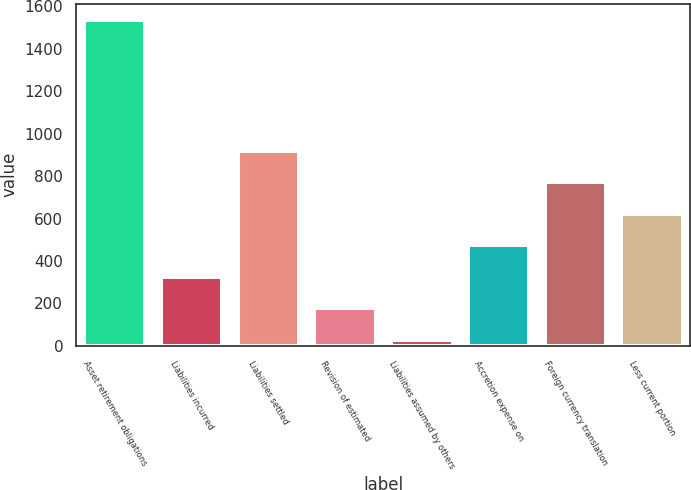Convert chart to OTSL. <chart><loc_0><loc_0><loc_500><loc_500><bar_chart><fcel>Asset retirement obligations<fcel>Liabilities incurred<fcel>Liabilities settled<fcel>Revision of estimated<fcel>Liabilities assumed by others<fcel>Accretion expense on<fcel>Foreign currency translation<fcel>Less current portion<nl><fcel>1535.3<fcel>326.6<fcel>919.8<fcel>178.3<fcel>30<fcel>474.9<fcel>771.5<fcel>623.2<nl></chart> 